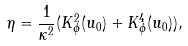Convert formula to latex. <formula><loc_0><loc_0><loc_500><loc_500>\eta = \frac { 1 } { \kappa ^ { 2 } } ( K ^ { 2 } _ { \phi } ( u _ { 0 } ) + K ^ { 4 } _ { \phi } ( u _ { 0 } ) ) ,</formula> 